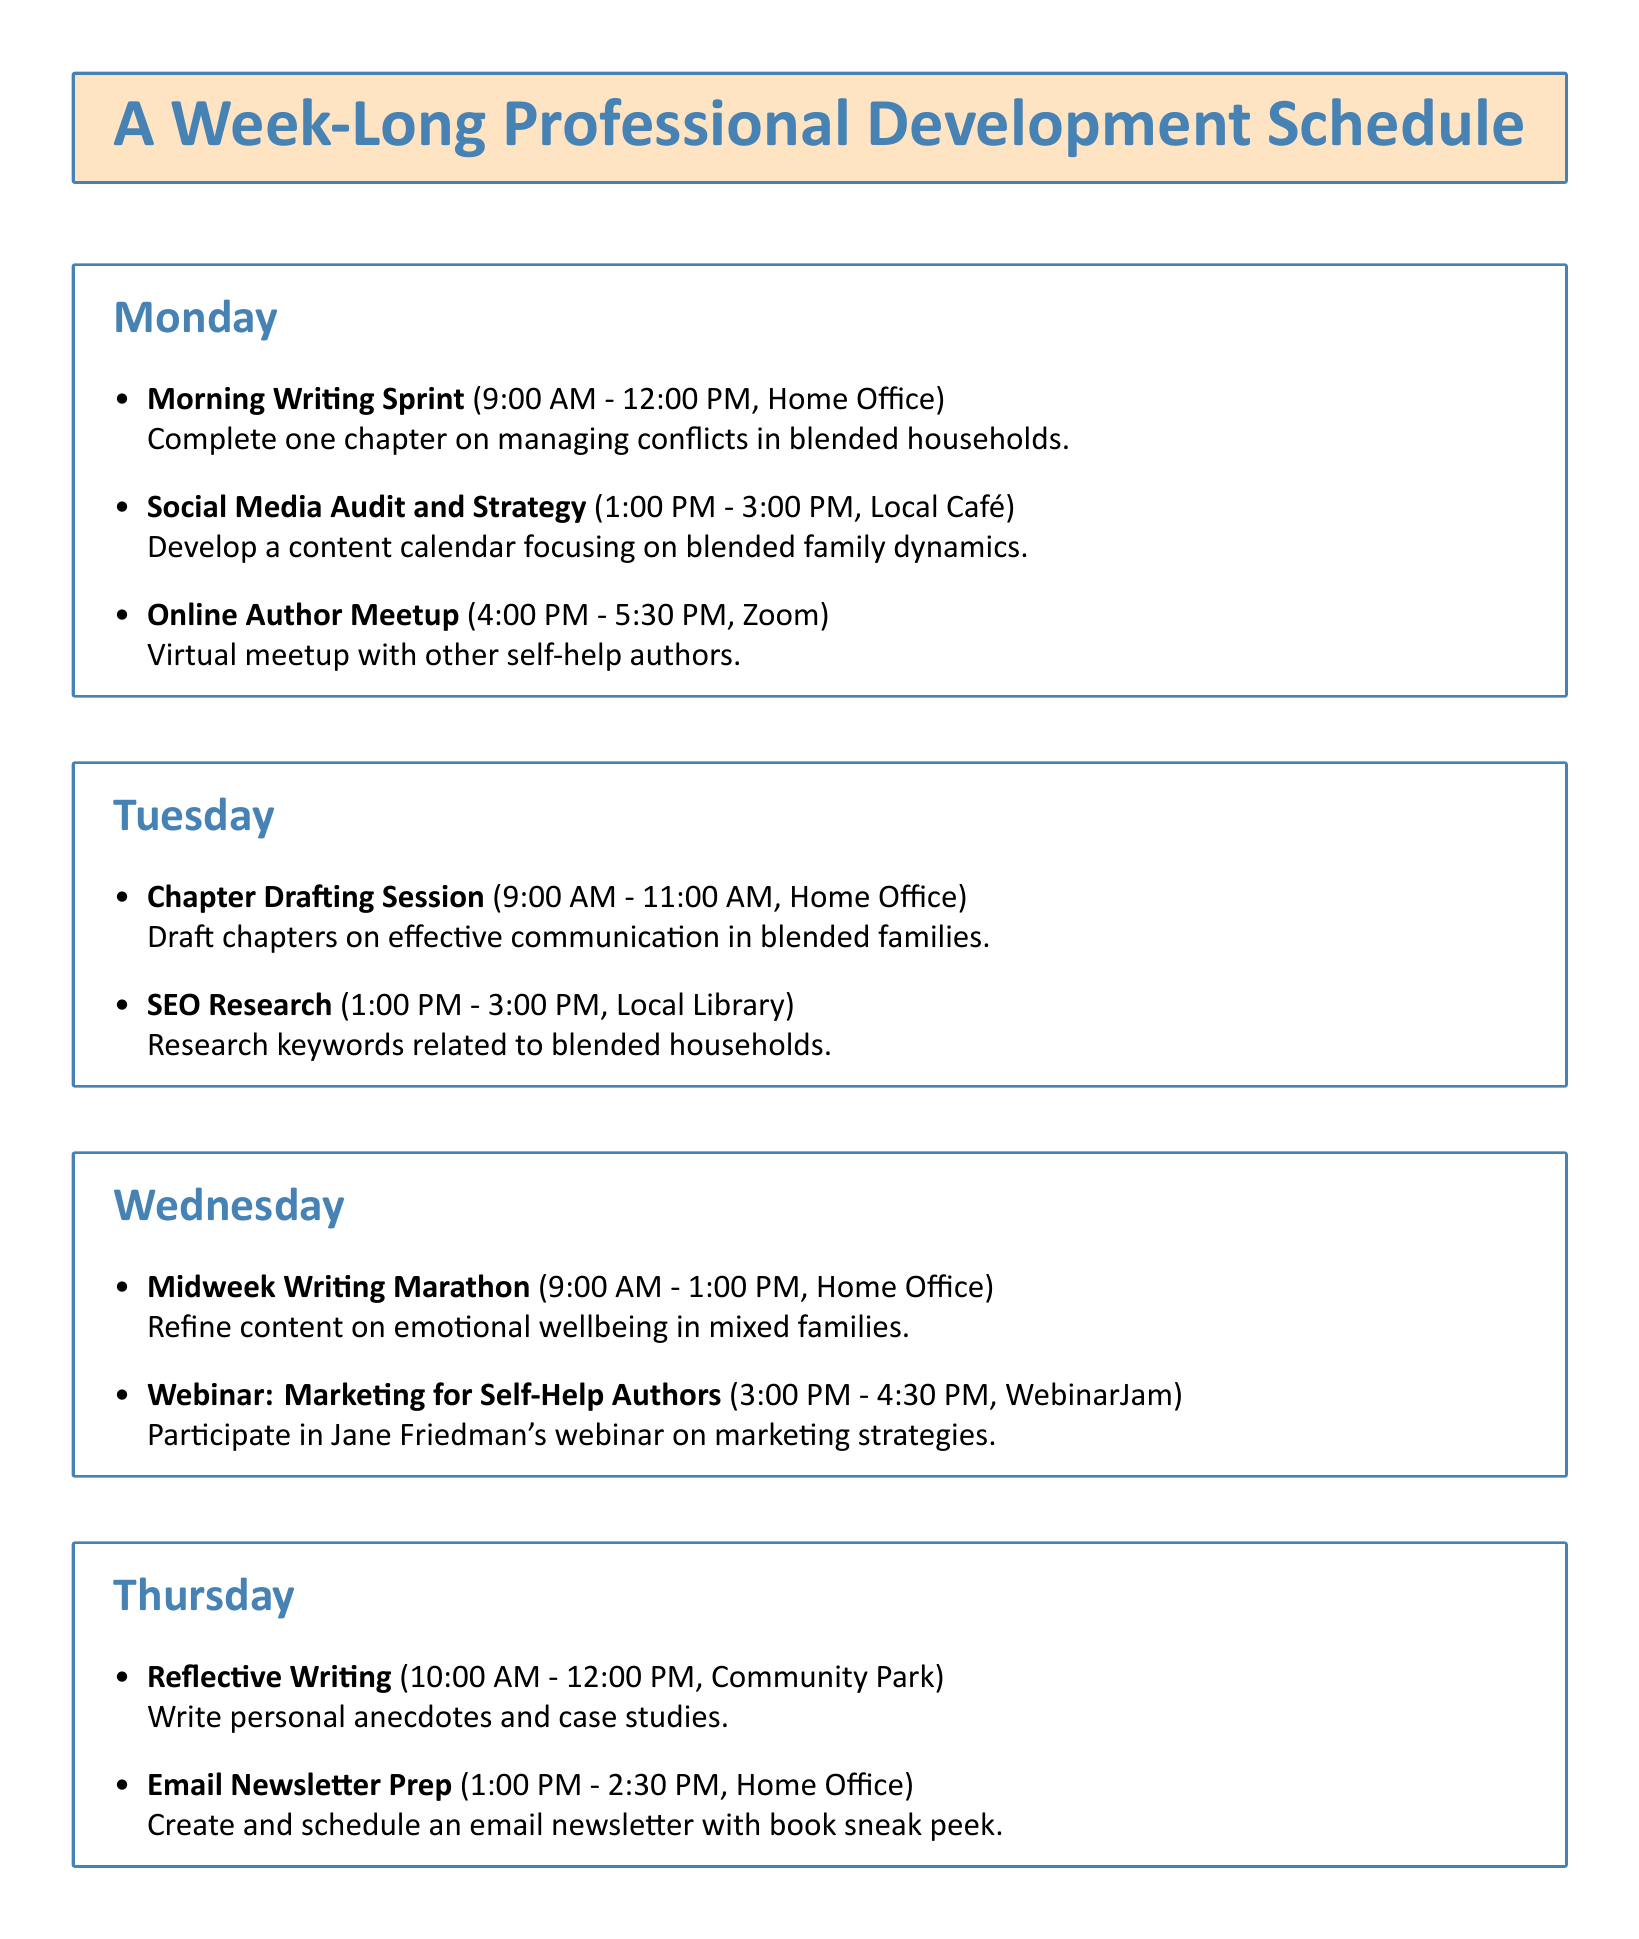What time does the Midweek Writing Marathon start? The Midweek Writing Marathon starts at 9:00 AM on Wednesday.
Answer: 9:00 AM What is the location for the Webinar: Marketing for Self-Help Authors? The location for the webinar is WebinarJam.
Answer: WebinarJam How many hours are allocated for the Wrap-Up Writing Session? The Wrap-Up Writing Session is scheduled for 2 hours, from 9:00 AM to 11:00 AM on Friday.
Answer: 2 hours What chapter is to be completed during the Monday morning writing sprint? The chapter to be completed is on managing conflicts in blended households.
Answer: Managing conflicts in blended households What is the purpose of the email newsletter prepared on Thursday? The purpose of the email newsletter is to create and schedule a newsletter with a book sneak peek.
Answer: Book sneak peek What type of event is scheduled for Friday at 5:00 PM? The event scheduled is an in-person networking event for authors and publishers.
Answer: Networking event What activity will take place on Tuesday from 1:00 PM to 3:00 PM? The activity is SEO Research at the Local Library.
Answer: SEO Research How many sessions are scheduled on Wednesday? There are two sessions scheduled on Wednesday.
Answer: Two sessions What is the theme of the social media audit conducted on Monday? The theme is focusing on blended family dynamics.
Answer: Blended family dynamics 